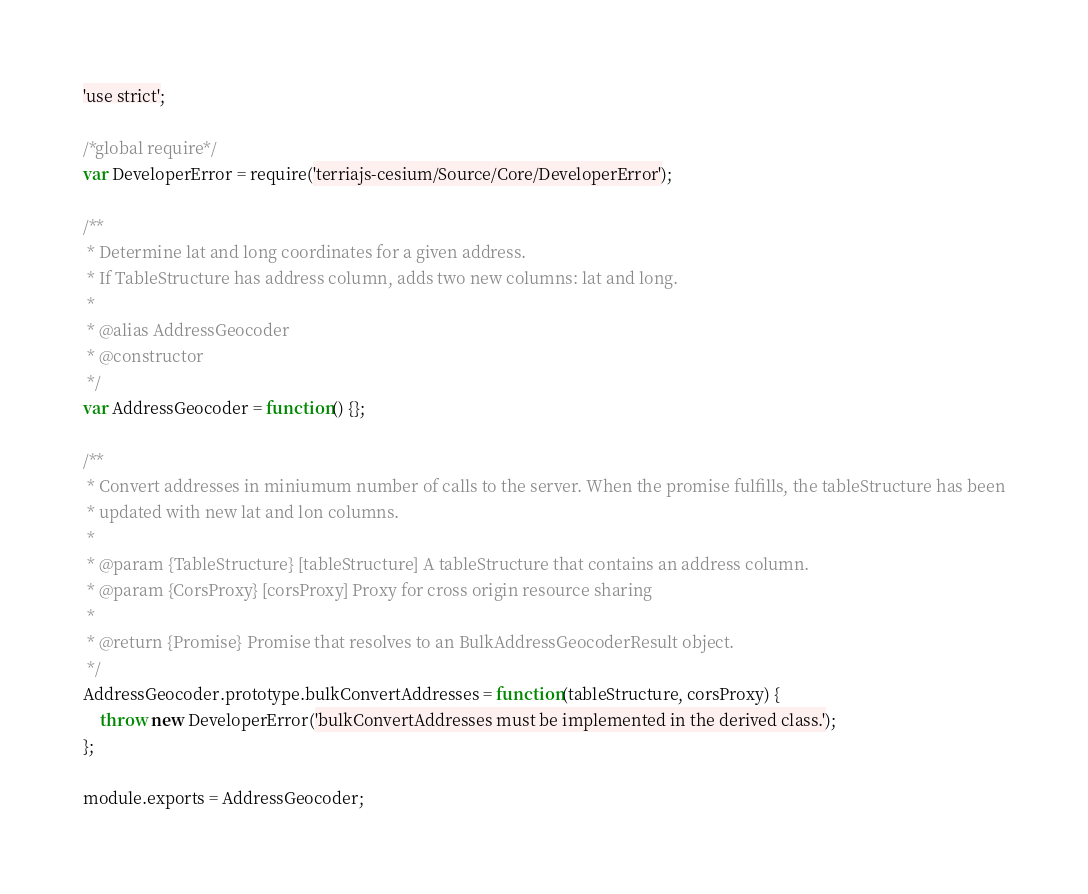Convert code to text. <code><loc_0><loc_0><loc_500><loc_500><_JavaScript_>'use strict';

/*global require*/
var DeveloperError = require('terriajs-cesium/Source/Core/DeveloperError');

/**
 * Determine lat and long coordinates for a given address.
 * If TableStructure has address column, adds two new columns: lat and long.
 *
 * @alias AddressGeocoder
 * @constructor
 */
var AddressGeocoder = function() {};

/**
 * Convert addresses in miniumum number of calls to the server. When the promise fulfills, the tableStructure has been
 * updated with new lat and lon columns.
 *
 * @param {TableStructure} [tableStructure] A tableStructure that contains an address column.
 * @param {CorsProxy} [corsProxy] Proxy for cross origin resource sharing
 *
 * @return {Promise} Promise that resolves to an BulkAddressGeocoderResult object.
 */
AddressGeocoder.prototype.bulkConvertAddresses = function(tableStructure, corsProxy) {
    throw new DeveloperError('bulkConvertAddresses must be implemented in the derived class.');
};

module.exports = AddressGeocoder;
</code> 